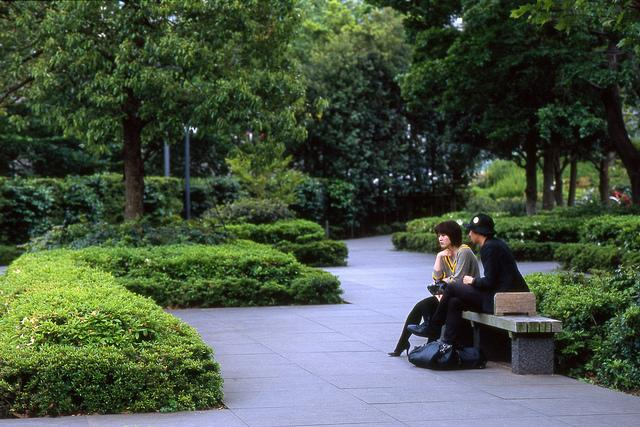How many people are sitting on the bench in the middle of the park? two 